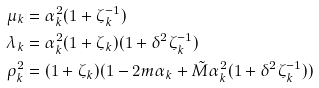<formula> <loc_0><loc_0><loc_500><loc_500>\mu _ { k } & = \alpha _ { k } ^ { 2 } ( 1 + \zeta _ { k } ^ { - 1 } ) \\ \lambda _ { k } & = \alpha _ { k } ^ { 2 } ( 1 + \zeta _ { k } ) ( 1 + \delta ^ { 2 } \zeta _ { k } ^ { - 1 } ) \\ \rho _ { k } ^ { 2 } & = ( 1 + \zeta _ { k } ) ( 1 - 2 m \alpha _ { k } + \tilde { M } \alpha _ { k } ^ { 2 } ( 1 + \delta ^ { 2 } \zeta _ { k } ^ { - 1 } ) )</formula> 